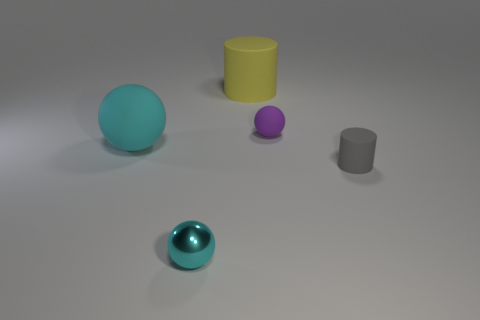Add 3 small blue rubber objects. How many objects exist? 8 Subtract all cylinders. How many objects are left? 3 Subtract all purple rubber things. Subtract all small purple spheres. How many objects are left? 3 Add 2 cyan rubber things. How many cyan rubber things are left? 3 Add 4 small purple rubber balls. How many small purple rubber balls exist? 5 Subtract 1 purple balls. How many objects are left? 4 